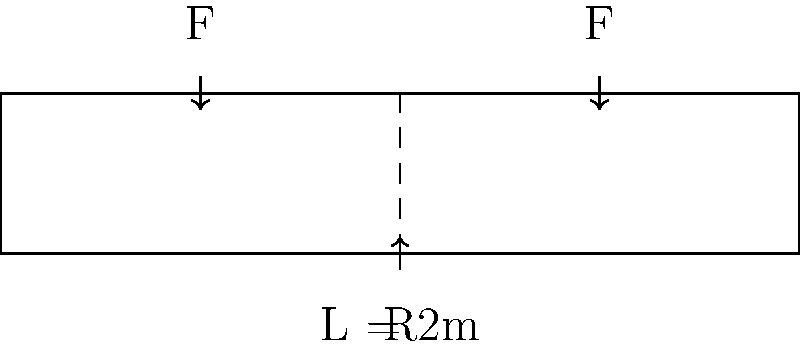A hospital bed frame is modeled as a simply supported beam with a length of 2 meters. Two equal point loads F, representing patient weight, are applied at quarter points along the beam. If the maximum allowable stress in the beam is 200 MPa and the beam has a rectangular cross-section with a width of 50 mm and a height of 100 mm, what is the maximum patient weight that can be safely supported? Let's approach this step-by-step:

1) First, we need to calculate the moment of inertia (I) for the rectangular cross-section:
   $$I = \frac{bh^3}{12} = \frac{50 \times 100^3}{12} = 4.17 \times 10^6 \text{ mm}^4$$

2) The maximum bending moment (M) occurs at the center of the beam. For two equal loads F at quarter points:
   $$M = \frac{FL}{2} = \frac{F \times 2000}{2} = 1000F \text{ N⋅mm}$$

3) The maximum stress (σ) in a beam is given by:
   $$\sigma = \frac{My}{I}$$
   where y is the distance from the neutral axis to the outer fiber (half the height of the beam).

4) Substituting the known values:
   $$200 = \frac{1000F \times 50}{4.17 \times 10^6}$$

5) Solving for F:
   $$F = \frac{200 \times 4.17 \times 10^6}{1000 \times 50} = 16,680 \text{ N}$$

6) This is the total load, which is twice the patient weight. So the maximum patient weight is:
   $$\text{Patient Weight} = \frac{16,680}{2} = 8,340 \text{ N} \approx 850 \text{ kg}$$
Answer: 850 kg 